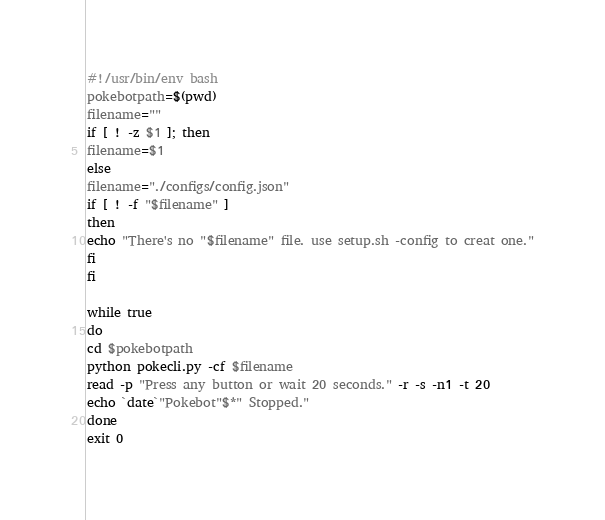<code> <loc_0><loc_0><loc_500><loc_500><_Bash_>#!/usr/bin/env bash
pokebotpath=$(pwd)
filename=""
if [ ! -z $1 ]; then
filename=$1
else
filename="./configs/config.json"
if [ ! -f "$filename" ]
then
echo "There's no "$filename" file. use setup.sh -config to creat one."
fi
fi

while true
do
cd $pokebotpath
python pokecli.py -cf $filename
read -p "Press any button or wait 20 seconds." -r -s -n1 -t 20
echo `date`"Pokebot"$*" Stopped." 
done
exit 0
</code> 